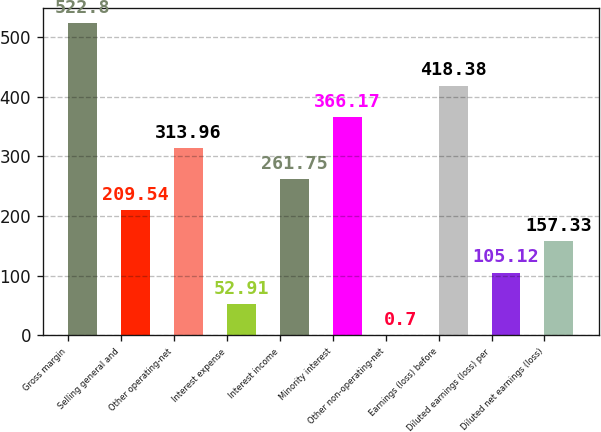Convert chart. <chart><loc_0><loc_0><loc_500><loc_500><bar_chart><fcel>Gross margin<fcel>Selling general and<fcel>Other operating-net<fcel>Interest expense<fcel>Interest income<fcel>Minority interest<fcel>Other non-operating-net<fcel>Earnings (loss) before<fcel>Diluted earnings (loss) per<fcel>Diluted net earnings (loss)<nl><fcel>522.8<fcel>209.54<fcel>313.96<fcel>52.91<fcel>261.75<fcel>366.17<fcel>0.7<fcel>418.38<fcel>105.12<fcel>157.33<nl></chart> 